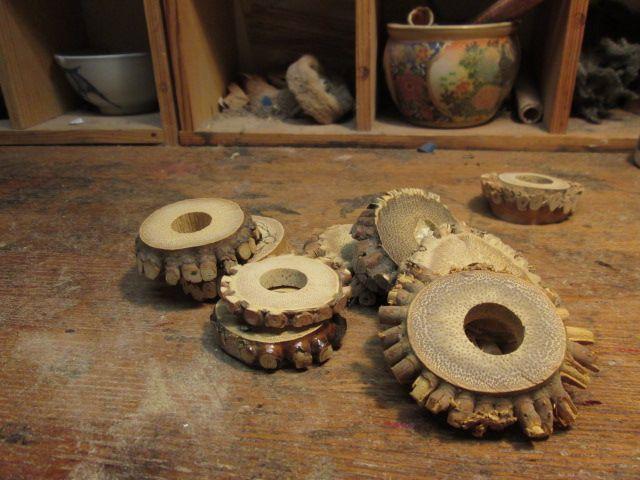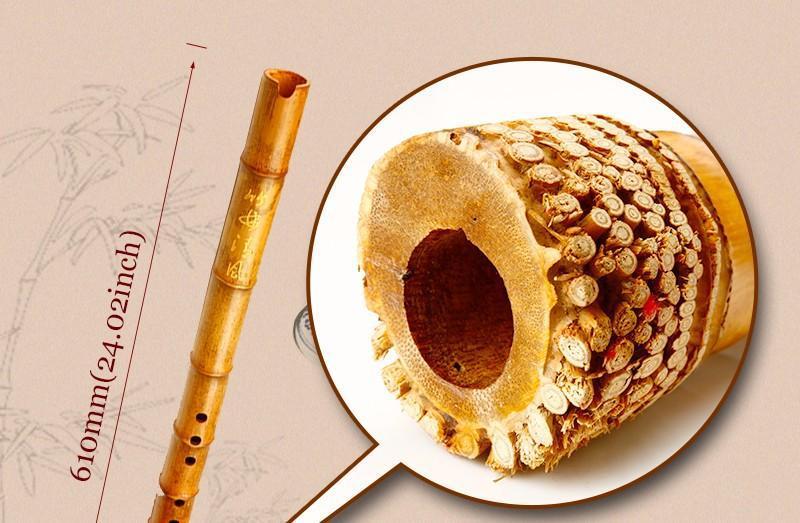The first image is the image on the left, the second image is the image on the right. Assess this claim about the two images: "there is a dark satined wood flute on a wooden table with a multicolored leaf on it". Correct or not? Answer yes or no. No. 